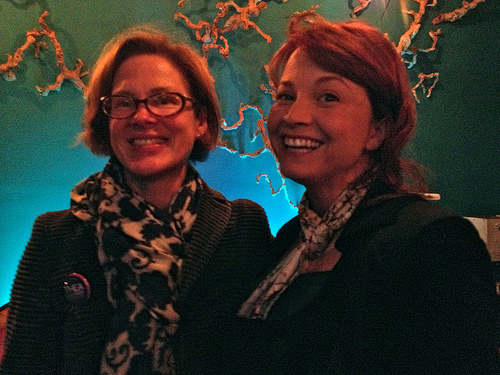<image>
Is the frowning man in front of the angry woman? No. The frowning man is not in front of the angry woman. The spatial positioning shows a different relationship between these objects. 